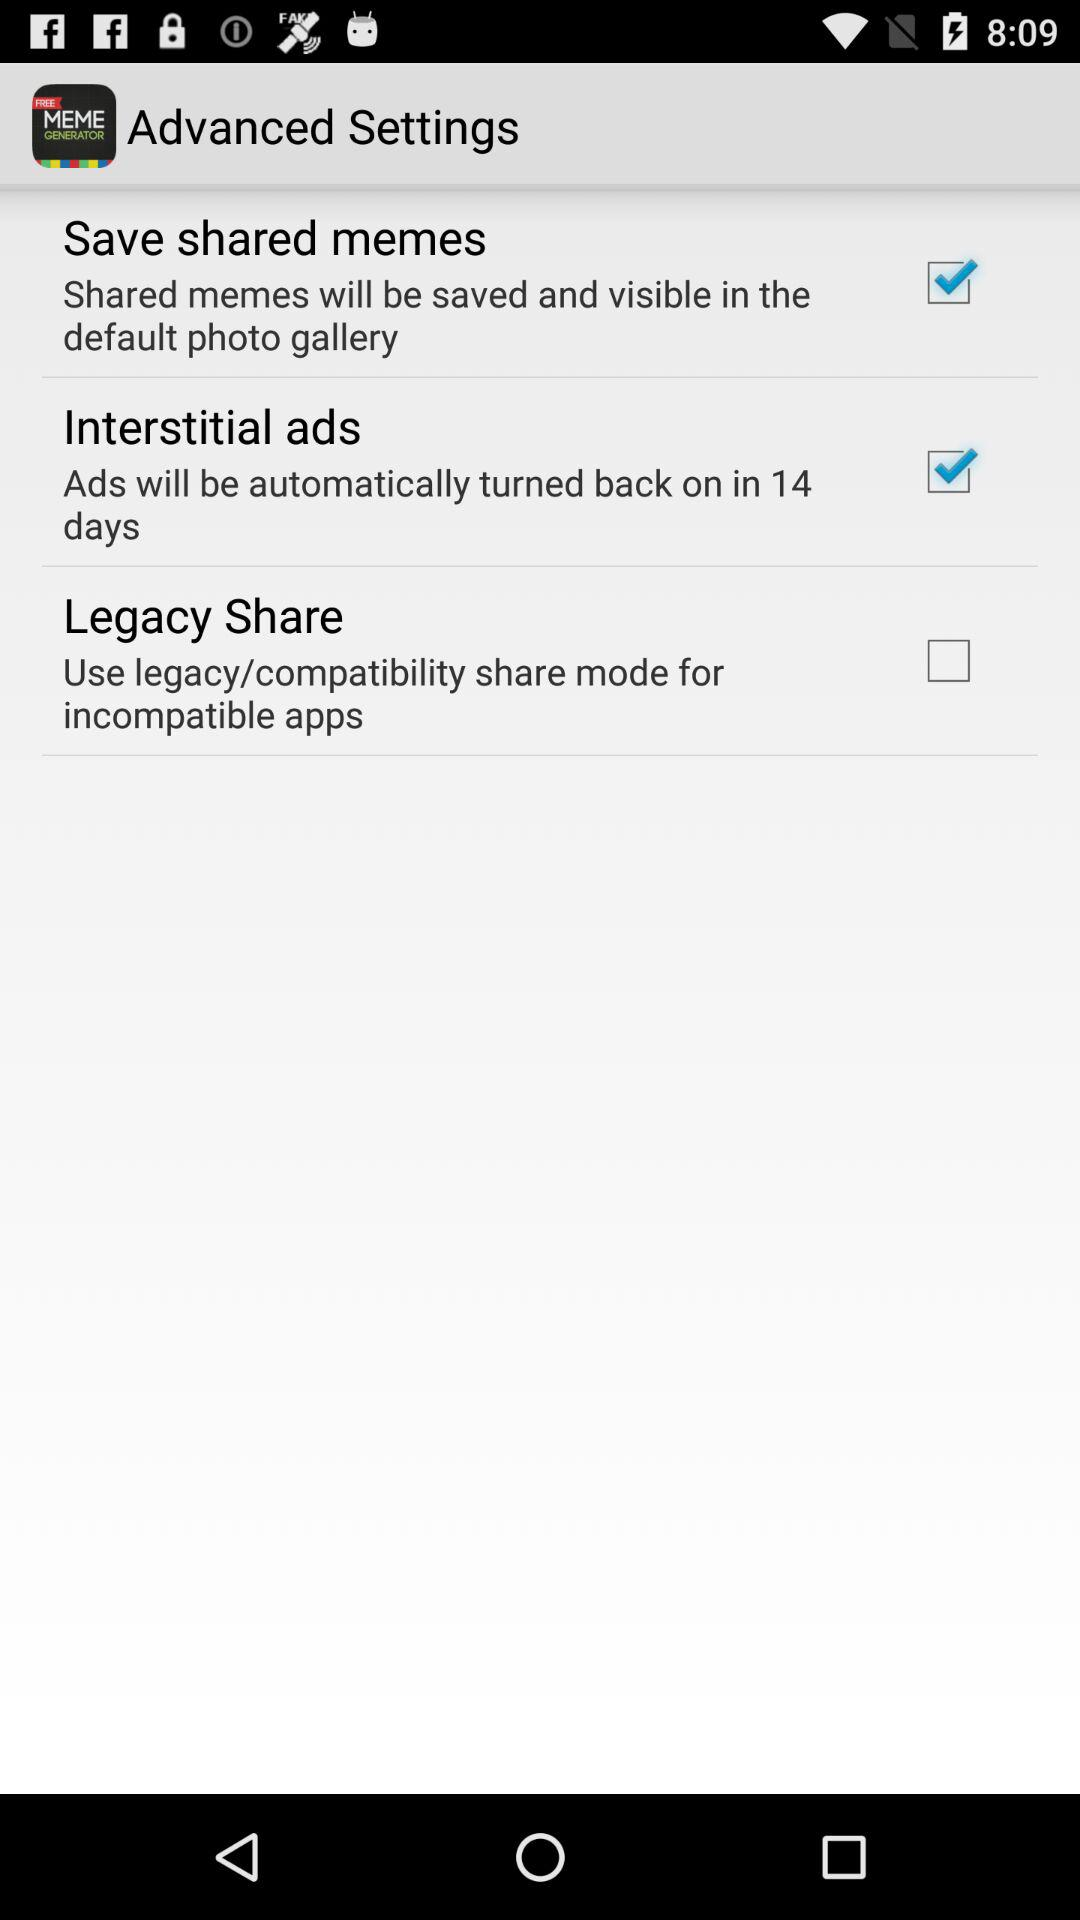Which option should we select so that ads will be automatically turned back on in 14 days? The option is "Interstitial ads". 